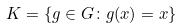Convert formula to latex. <formula><loc_0><loc_0><loc_500><loc_500>K = \{ g \in G \colon g ( x ) = x \}</formula> 